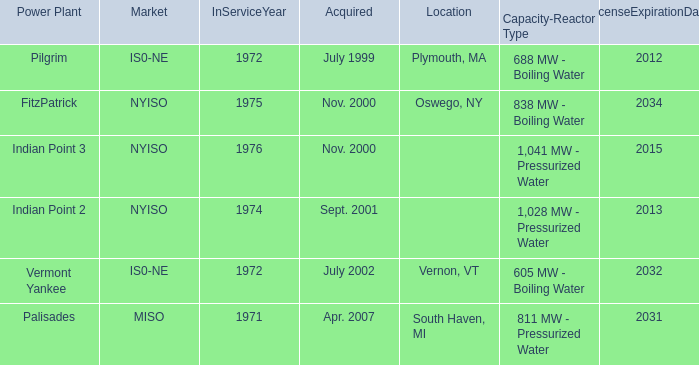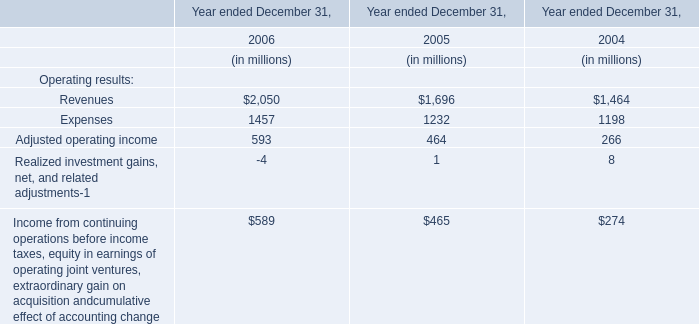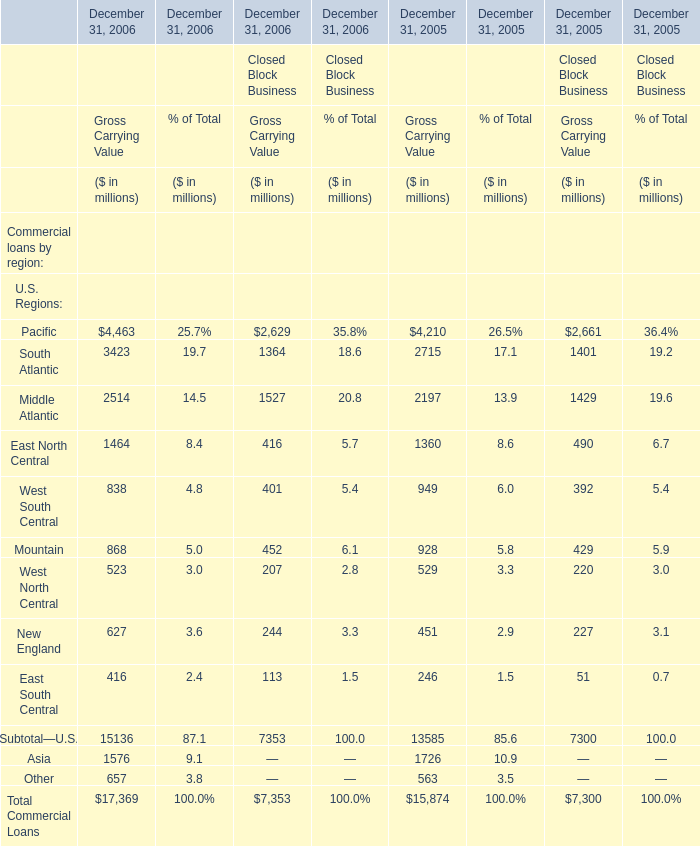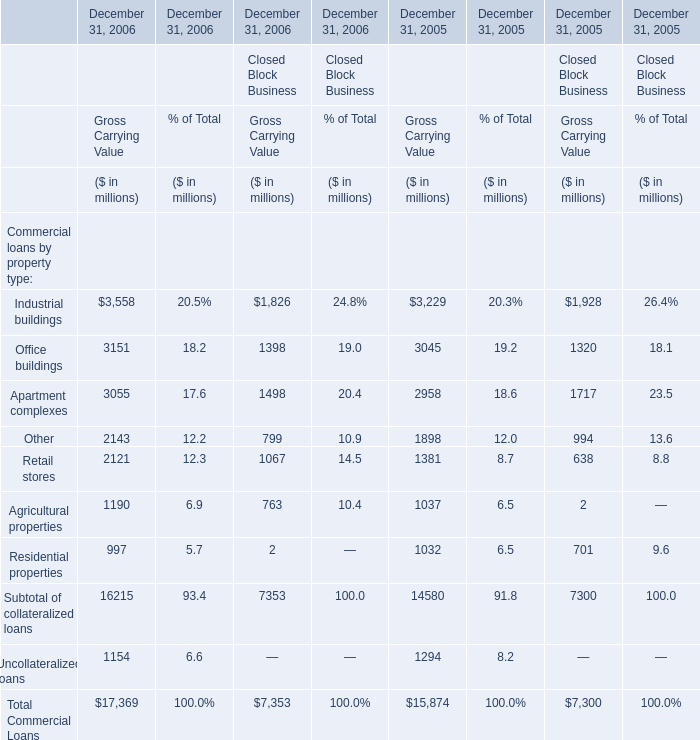In what year is Industrial buildings positive for Gross Carrying Value ,Financial Services Businesses 
Answer: December 31, 2006 December 31, 2005. 